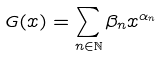Convert formula to latex. <formula><loc_0><loc_0><loc_500><loc_500>G ( x ) = \sum _ { n \in \mathbb { N } } \beta _ { n } x ^ { \alpha _ { n } }</formula> 